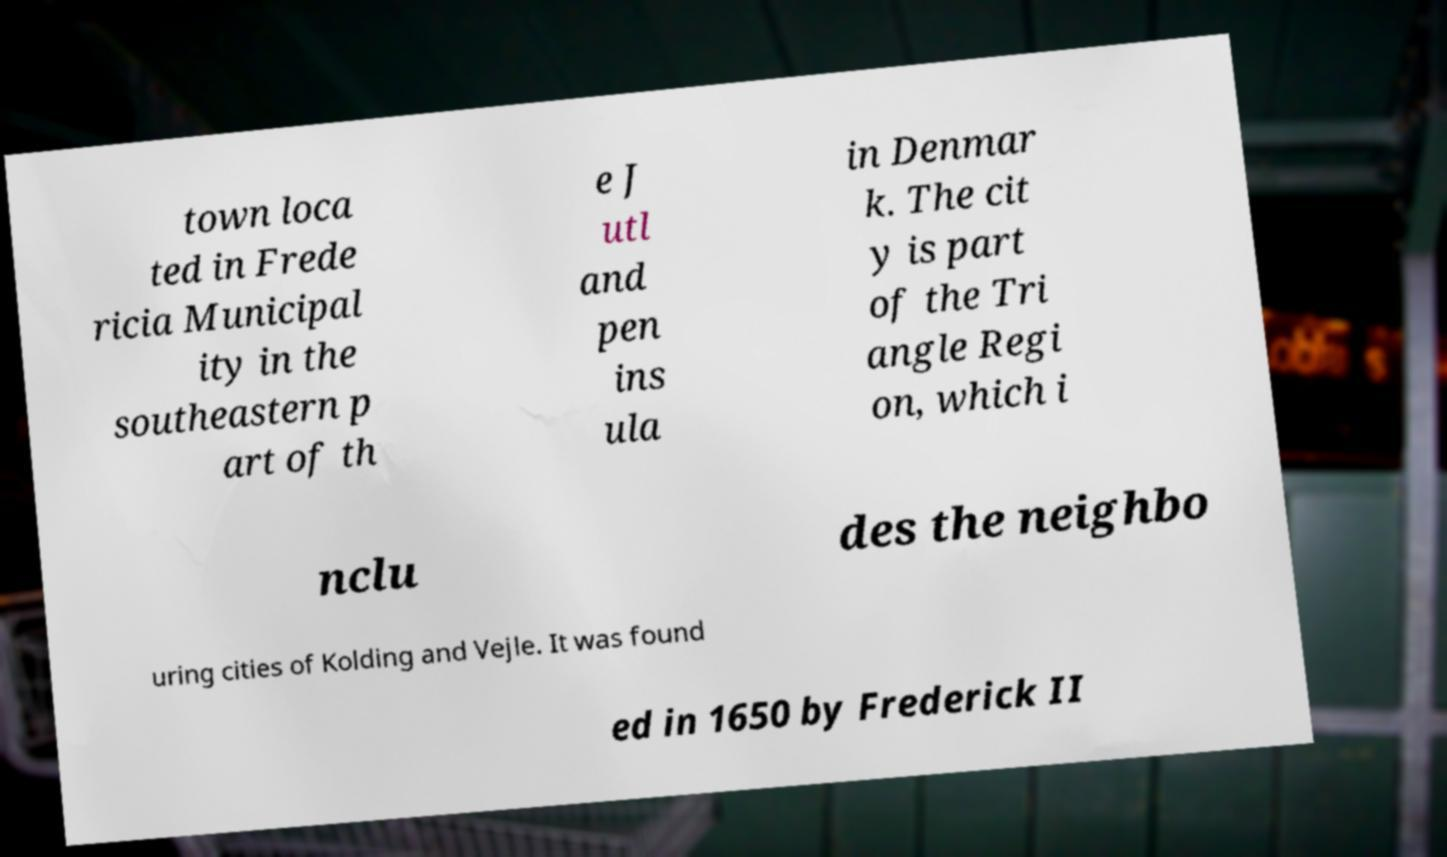Could you extract and type out the text from this image? town loca ted in Frede ricia Municipal ity in the southeastern p art of th e J utl and pen ins ula in Denmar k. The cit y is part of the Tri angle Regi on, which i nclu des the neighbo uring cities of Kolding and Vejle. It was found ed in 1650 by Frederick II 